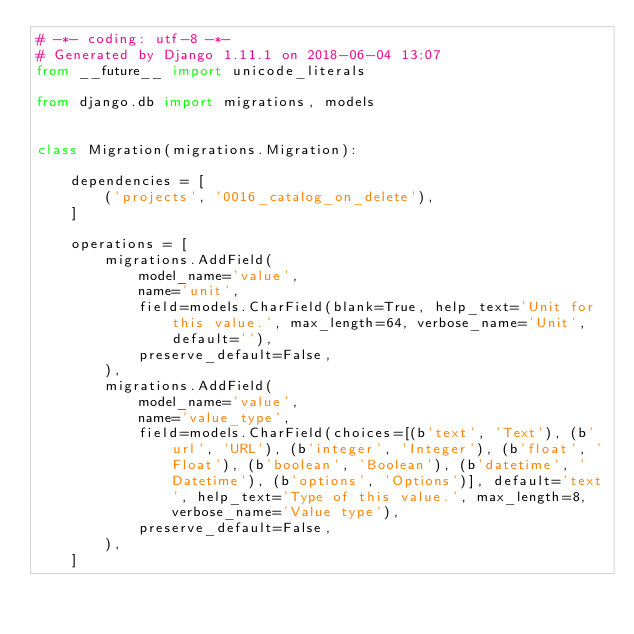<code> <loc_0><loc_0><loc_500><loc_500><_Python_># -*- coding: utf-8 -*-
# Generated by Django 1.11.1 on 2018-06-04 13:07
from __future__ import unicode_literals

from django.db import migrations, models


class Migration(migrations.Migration):

    dependencies = [
        ('projects', '0016_catalog_on_delete'),
    ]

    operations = [
        migrations.AddField(
            model_name='value',
            name='unit',
            field=models.CharField(blank=True, help_text='Unit for this value.', max_length=64, verbose_name='Unit', default=''),
            preserve_default=False,
        ),
        migrations.AddField(
            model_name='value',
            name='value_type',
            field=models.CharField(choices=[(b'text', 'Text'), (b'url', 'URL'), (b'integer', 'Integer'), (b'float', 'Float'), (b'boolean', 'Boolean'), (b'datetime', 'Datetime'), (b'options', 'Options')], default='text', help_text='Type of this value.', max_length=8, verbose_name='Value type'),
            preserve_default=False,
        ),
    ]
</code> 